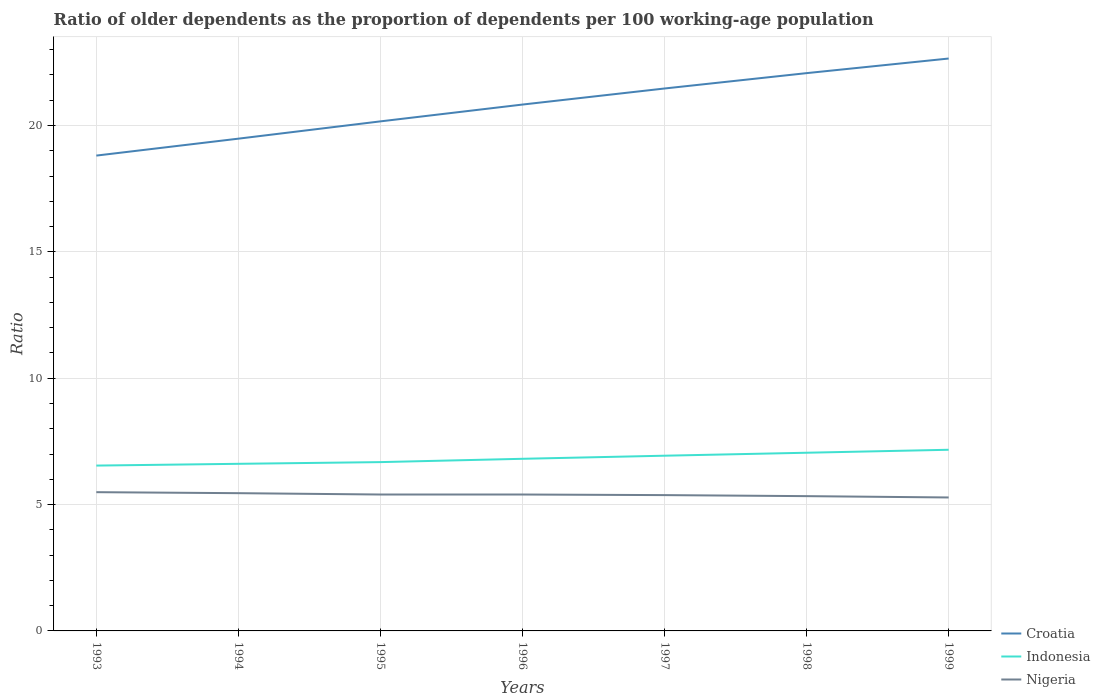How many different coloured lines are there?
Your response must be concise. 3. Does the line corresponding to Croatia intersect with the line corresponding to Nigeria?
Make the answer very short. No. Across all years, what is the maximum age dependency ratio(old) in Croatia?
Give a very brief answer. 18.81. In which year was the age dependency ratio(old) in Nigeria maximum?
Keep it short and to the point. 1999. What is the total age dependency ratio(old) in Croatia in the graph?
Your answer should be compact. -0.64. What is the difference between the highest and the second highest age dependency ratio(old) in Croatia?
Offer a very short reply. 3.84. Does the graph contain any zero values?
Make the answer very short. No. Does the graph contain grids?
Your answer should be compact. Yes. What is the title of the graph?
Keep it short and to the point. Ratio of older dependents as the proportion of dependents per 100 working-age population. Does "Virgin Islands" appear as one of the legend labels in the graph?
Your answer should be compact. No. What is the label or title of the Y-axis?
Your response must be concise. Ratio. What is the Ratio of Croatia in 1993?
Ensure brevity in your answer.  18.81. What is the Ratio of Indonesia in 1993?
Your answer should be very brief. 6.54. What is the Ratio of Nigeria in 1993?
Your answer should be compact. 5.49. What is the Ratio of Croatia in 1994?
Your response must be concise. 19.48. What is the Ratio in Indonesia in 1994?
Make the answer very short. 6.61. What is the Ratio in Nigeria in 1994?
Provide a short and direct response. 5.45. What is the Ratio of Croatia in 1995?
Your response must be concise. 20.16. What is the Ratio in Indonesia in 1995?
Provide a short and direct response. 6.68. What is the Ratio in Nigeria in 1995?
Offer a terse response. 5.4. What is the Ratio in Croatia in 1996?
Provide a succinct answer. 20.83. What is the Ratio in Indonesia in 1996?
Your response must be concise. 6.81. What is the Ratio of Nigeria in 1996?
Keep it short and to the point. 5.4. What is the Ratio in Croatia in 1997?
Make the answer very short. 21.46. What is the Ratio in Indonesia in 1997?
Your response must be concise. 6.93. What is the Ratio of Nigeria in 1997?
Offer a very short reply. 5.37. What is the Ratio of Croatia in 1998?
Your answer should be compact. 22.07. What is the Ratio in Indonesia in 1998?
Your response must be concise. 7.05. What is the Ratio of Nigeria in 1998?
Your answer should be compact. 5.33. What is the Ratio in Croatia in 1999?
Your response must be concise. 22.65. What is the Ratio of Indonesia in 1999?
Your response must be concise. 7.17. What is the Ratio of Nigeria in 1999?
Provide a short and direct response. 5.28. Across all years, what is the maximum Ratio in Croatia?
Offer a terse response. 22.65. Across all years, what is the maximum Ratio of Indonesia?
Your answer should be compact. 7.17. Across all years, what is the maximum Ratio of Nigeria?
Provide a succinct answer. 5.49. Across all years, what is the minimum Ratio of Croatia?
Your answer should be very brief. 18.81. Across all years, what is the minimum Ratio of Indonesia?
Offer a terse response. 6.54. Across all years, what is the minimum Ratio of Nigeria?
Offer a very short reply. 5.28. What is the total Ratio of Croatia in the graph?
Provide a short and direct response. 145.47. What is the total Ratio of Indonesia in the graph?
Give a very brief answer. 47.8. What is the total Ratio in Nigeria in the graph?
Ensure brevity in your answer.  37.73. What is the difference between the Ratio of Croatia in 1993 and that in 1994?
Ensure brevity in your answer.  -0.67. What is the difference between the Ratio in Indonesia in 1993 and that in 1994?
Your answer should be very brief. -0.07. What is the difference between the Ratio in Nigeria in 1993 and that in 1994?
Ensure brevity in your answer.  0.04. What is the difference between the Ratio of Croatia in 1993 and that in 1995?
Provide a succinct answer. -1.35. What is the difference between the Ratio of Indonesia in 1993 and that in 1995?
Offer a very short reply. -0.14. What is the difference between the Ratio of Nigeria in 1993 and that in 1995?
Your answer should be compact. 0.09. What is the difference between the Ratio of Croatia in 1993 and that in 1996?
Ensure brevity in your answer.  -2.02. What is the difference between the Ratio of Indonesia in 1993 and that in 1996?
Make the answer very short. -0.27. What is the difference between the Ratio in Nigeria in 1993 and that in 1996?
Your response must be concise. 0.09. What is the difference between the Ratio of Croatia in 1993 and that in 1997?
Give a very brief answer. -2.65. What is the difference between the Ratio of Indonesia in 1993 and that in 1997?
Keep it short and to the point. -0.39. What is the difference between the Ratio of Nigeria in 1993 and that in 1997?
Give a very brief answer. 0.12. What is the difference between the Ratio in Croatia in 1993 and that in 1998?
Ensure brevity in your answer.  -3.26. What is the difference between the Ratio in Indonesia in 1993 and that in 1998?
Offer a terse response. -0.51. What is the difference between the Ratio of Nigeria in 1993 and that in 1998?
Provide a short and direct response. 0.16. What is the difference between the Ratio in Croatia in 1993 and that in 1999?
Provide a short and direct response. -3.84. What is the difference between the Ratio in Indonesia in 1993 and that in 1999?
Offer a terse response. -0.63. What is the difference between the Ratio in Nigeria in 1993 and that in 1999?
Offer a very short reply. 0.21. What is the difference between the Ratio in Croatia in 1994 and that in 1995?
Your response must be concise. -0.68. What is the difference between the Ratio of Indonesia in 1994 and that in 1995?
Offer a terse response. -0.07. What is the difference between the Ratio of Nigeria in 1994 and that in 1995?
Your answer should be compact. 0.05. What is the difference between the Ratio in Croatia in 1994 and that in 1996?
Provide a short and direct response. -1.35. What is the difference between the Ratio of Indonesia in 1994 and that in 1996?
Provide a succinct answer. -0.2. What is the difference between the Ratio in Nigeria in 1994 and that in 1996?
Offer a terse response. 0.05. What is the difference between the Ratio in Croatia in 1994 and that in 1997?
Keep it short and to the point. -1.99. What is the difference between the Ratio of Indonesia in 1994 and that in 1997?
Give a very brief answer. -0.32. What is the difference between the Ratio of Nigeria in 1994 and that in 1997?
Your response must be concise. 0.08. What is the difference between the Ratio of Croatia in 1994 and that in 1998?
Make the answer very short. -2.59. What is the difference between the Ratio in Indonesia in 1994 and that in 1998?
Provide a short and direct response. -0.44. What is the difference between the Ratio in Nigeria in 1994 and that in 1998?
Provide a succinct answer. 0.12. What is the difference between the Ratio in Croatia in 1994 and that in 1999?
Give a very brief answer. -3.17. What is the difference between the Ratio of Indonesia in 1994 and that in 1999?
Make the answer very short. -0.56. What is the difference between the Ratio in Nigeria in 1994 and that in 1999?
Your answer should be compact. 0.17. What is the difference between the Ratio of Croatia in 1995 and that in 1996?
Ensure brevity in your answer.  -0.67. What is the difference between the Ratio of Indonesia in 1995 and that in 1996?
Your response must be concise. -0.13. What is the difference between the Ratio in Croatia in 1995 and that in 1997?
Provide a succinct answer. -1.3. What is the difference between the Ratio in Indonesia in 1995 and that in 1997?
Provide a short and direct response. -0.25. What is the difference between the Ratio of Nigeria in 1995 and that in 1997?
Provide a short and direct response. 0.02. What is the difference between the Ratio of Croatia in 1995 and that in 1998?
Your answer should be compact. -1.91. What is the difference between the Ratio in Indonesia in 1995 and that in 1998?
Your answer should be very brief. -0.37. What is the difference between the Ratio in Nigeria in 1995 and that in 1998?
Provide a short and direct response. 0.06. What is the difference between the Ratio of Croatia in 1995 and that in 1999?
Your answer should be compact. -2.49. What is the difference between the Ratio in Indonesia in 1995 and that in 1999?
Keep it short and to the point. -0.49. What is the difference between the Ratio of Nigeria in 1995 and that in 1999?
Ensure brevity in your answer.  0.12. What is the difference between the Ratio of Croatia in 1996 and that in 1997?
Provide a succinct answer. -0.64. What is the difference between the Ratio in Indonesia in 1996 and that in 1997?
Provide a short and direct response. -0.12. What is the difference between the Ratio of Nigeria in 1996 and that in 1997?
Your response must be concise. 0.02. What is the difference between the Ratio of Croatia in 1996 and that in 1998?
Provide a succinct answer. -1.24. What is the difference between the Ratio in Indonesia in 1996 and that in 1998?
Make the answer very short. -0.24. What is the difference between the Ratio of Nigeria in 1996 and that in 1998?
Your answer should be very brief. 0.06. What is the difference between the Ratio of Croatia in 1996 and that in 1999?
Keep it short and to the point. -1.82. What is the difference between the Ratio in Indonesia in 1996 and that in 1999?
Your response must be concise. -0.36. What is the difference between the Ratio in Nigeria in 1996 and that in 1999?
Keep it short and to the point. 0.12. What is the difference between the Ratio of Croatia in 1997 and that in 1998?
Offer a very short reply. -0.61. What is the difference between the Ratio in Indonesia in 1997 and that in 1998?
Provide a short and direct response. -0.12. What is the difference between the Ratio in Nigeria in 1997 and that in 1998?
Give a very brief answer. 0.04. What is the difference between the Ratio of Croatia in 1997 and that in 1999?
Keep it short and to the point. -1.19. What is the difference between the Ratio of Indonesia in 1997 and that in 1999?
Your answer should be very brief. -0.24. What is the difference between the Ratio in Nigeria in 1997 and that in 1999?
Provide a succinct answer. 0.09. What is the difference between the Ratio of Croatia in 1998 and that in 1999?
Provide a short and direct response. -0.58. What is the difference between the Ratio in Indonesia in 1998 and that in 1999?
Offer a very short reply. -0.12. What is the difference between the Ratio in Nigeria in 1998 and that in 1999?
Keep it short and to the point. 0.05. What is the difference between the Ratio in Croatia in 1993 and the Ratio in Indonesia in 1994?
Offer a very short reply. 12.2. What is the difference between the Ratio in Croatia in 1993 and the Ratio in Nigeria in 1994?
Your response must be concise. 13.36. What is the difference between the Ratio of Indonesia in 1993 and the Ratio of Nigeria in 1994?
Provide a succinct answer. 1.09. What is the difference between the Ratio in Croatia in 1993 and the Ratio in Indonesia in 1995?
Your response must be concise. 12.13. What is the difference between the Ratio of Croatia in 1993 and the Ratio of Nigeria in 1995?
Your answer should be very brief. 13.41. What is the difference between the Ratio of Indonesia in 1993 and the Ratio of Nigeria in 1995?
Your answer should be compact. 1.14. What is the difference between the Ratio of Croatia in 1993 and the Ratio of Indonesia in 1996?
Provide a succinct answer. 12. What is the difference between the Ratio of Croatia in 1993 and the Ratio of Nigeria in 1996?
Offer a very short reply. 13.41. What is the difference between the Ratio of Indonesia in 1993 and the Ratio of Nigeria in 1996?
Offer a very short reply. 1.15. What is the difference between the Ratio of Croatia in 1993 and the Ratio of Indonesia in 1997?
Provide a short and direct response. 11.88. What is the difference between the Ratio in Croatia in 1993 and the Ratio in Nigeria in 1997?
Provide a succinct answer. 13.44. What is the difference between the Ratio in Indonesia in 1993 and the Ratio in Nigeria in 1997?
Provide a short and direct response. 1.17. What is the difference between the Ratio of Croatia in 1993 and the Ratio of Indonesia in 1998?
Make the answer very short. 11.76. What is the difference between the Ratio of Croatia in 1993 and the Ratio of Nigeria in 1998?
Offer a terse response. 13.48. What is the difference between the Ratio in Indonesia in 1993 and the Ratio in Nigeria in 1998?
Make the answer very short. 1.21. What is the difference between the Ratio of Croatia in 1993 and the Ratio of Indonesia in 1999?
Keep it short and to the point. 11.64. What is the difference between the Ratio in Croatia in 1993 and the Ratio in Nigeria in 1999?
Make the answer very short. 13.53. What is the difference between the Ratio in Indonesia in 1993 and the Ratio in Nigeria in 1999?
Provide a succinct answer. 1.26. What is the difference between the Ratio in Croatia in 1994 and the Ratio in Indonesia in 1995?
Offer a terse response. 12.8. What is the difference between the Ratio in Croatia in 1994 and the Ratio in Nigeria in 1995?
Your response must be concise. 14.08. What is the difference between the Ratio of Indonesia in 1994 and the Ratio of Nigeria in 1995?
Ensure brevity in your answer.  1.21. What is the difference between the Ratio in Croatia in 1994 and the Ratio in Indonesia in 1996?
Ensure brevity in your answer.  12.67. What is the difference between the Ratio of Croatia in 1994 and the Ratio of Nigeria in 1996?
Ensure brevity in your answer.  14.08. What is the difference between the Ratio in Indonesia in 1994 and the Ratio in Nigeria in 1996?
Your answer should be very brief. 1.22. What is the difference between the Ratio in Croatia in 1994 and the Ratio in Indonesia in 1997?
Give a very brief answer. 12.55. What is the difference between the Ratio in Croatia in 1994 and the Ratio in Nigeria in 1997?
Give a very brief answer. 14.11. What is the difference between the Ratio in Indonesia in 1994 and the Ratio in Nigeria in 1997?
Your answer should be compact. 1.24. What is the difference between the Ratio of Croatia in 1994 and the Ratio of Indonesia in 1998?
Your answer should be very brief. 12.43. What is the difference between the Ratio of Croatia in 1994 and the Ratio of Nigeria in 1998?
Your answer should be very brief. 14.15. What is the difference between the Ratio in Indonesia in 1994 and the Ratio in Nigeria in 1998?
Ensure brevity in your answer.  1.28. What is the difference between the Ratio in Croatia in 1994 and the Ratio in Indonesia in 1999?
Offer a very short reply. 12.31. What is the difference between the Ratio in Croatia in 1994 and the Ratio in Nigeria in 1999?
Your answer should be compact. 14.2. What is the difference between the Ratio of Indonesia in 1994 and the Ratio of Nigeria in 1999?
Your answer should be very brief. 1.33. What is the difference between the Ratio in Croatia in 1995 and the Ratio in Indonesia in 1996?
Ensure brevity in your answer.  13.35. What is the difference between the Ratio of Croatia in 1995 and the Ratio of Nigeria in 1996?
Your answer should be compact. 14.77. What is the difference between the Ratio of Indonesia in 1995 and the Ratio of Nigeria in 1996?
Your response must be concise. 1.28. What is the difference between the Ratio of Croatia in 1995 and the Ratio of Indonesia in 1997?
Offer a very short reply. 13.23. What is the difference between the Ratio in Croatia in 1995 and the Ratio in Nigeria in 1997?
Your answer should be compact. 14.79. What is the difference between the Ratio of Indonesia in 1995 and the Ratio of Nigeria in 1997?
Your response must be concise. 1.31. What is the difference between the Ratio of Croatia in 1995 and the Ratio of Indonesia in 1998?
Provide a succinct answer. 13.11. What is the difference between the Ratio of Croatia in 1995 and the Ratio of Nigeria in 1998?
Make the answer very short. 14.83. What is the difference between the Ratio of Indonesia in 1995 and the Ratio of Nigeria in 1998?
Offer a very short reply. 1.35. What is the difference between the Ratio in Croatia in 1995 and the Ratio in Indonesia in 1999?
Give a very brief answer. 12.99. What is the difference between the Ratio of Croatia in 1995 and the Ratio of Nigeria in 1999?
Your answer should be compact. 14.88. What is the difference between the Ratio in Indonesia in 1995 and the Ratio in Nigeria in 1999?
Make the answer very short. 1.4. What is the difference between the Ratio in Croatia in 1996 and the Ratio in Indonesia in 1997?
Give a very brief answer. 13.9. What is the difference between the Ratio of Croatia in 1996 and the Ratio of Nigeria in 1997?
Your answer should be very brief. 15.45. What is the difference between the Ratio in Indonesia in 1996 and the Ratio in Nigeria in 1997?
Make the answer very short. 1.44. What is the difference between the Ratio of Croatia in 1996 and the Ratio of Indonesia in 1998?
Your answer should be compact. 13.78. What is the difference between the Ratio of Croatia in 1996 and the Ratio of Nigeria in 1998?
Make the answer very short. 15.5. What is the difference between the Ratio of Indonesia in 1996 and the Ratio of Nigeria in 1998?
Provide a succinct answer. 1.48. What is the difference between the Ratio in Croatia in 1996 and the Ratio in Indonesia in 1999?
Ensure brevity in your answer.  13.66. What is the difference between the Ratio in Croatia in 1996 and the Ratio in Nigeria in 1999?
Your answer should be compact. 15.55. What is the difference between the Ratio of Indonesia in 1996 and the Ratio of Nigeria in 1999?
Offer a terse response. 1.53. What is the difference between the Ratio of Croatia in 1997 and the Ratio of Indonesia in 1998?
Give a very brief answer. 14.41. What is the difference between the Ratio of Croatia in 1997 and the Ratio of Nigeria in 1998?
Make the answer very short. 16.13. What is the difference between the Ratio of Croatia in 1997 and the Ratio of Indonesia in 1999?
Your response must be concise. 14.3. What is the difference between the Ratio in Croatia in 1997 and the Ratio in Nigeria in 1999?
Your answer should be compact. 16.18. What is the difference between the Ratio in Indonesia in 1997 and the Ratio in Nigeria in 1999?
Ensure brevity in your answer.  1.65. What is the difference between the Ratio of Croatia in 1998 and the Ratio of Indonesia in 1999?
Your response must be concise. 14.9. What is the difference between the Ratio in Croatia in 1998 and the Ratio in Nigeria in 1999?
Your answer should be very brief. 16.79. What is the difference between the Ratio in Indonesia in 1998 and the Ratio in Nigeria in 1999?
Offer a very short reply. 1.77. What is the average Ratio in Croatia per year?
Provide a short and direct response. 20.78. What is the average Ratio of Indonesia per year?
Give a very brief answer. 6.83. What is the average Ratio in Nigeria per year?
Keep it short and to the point. 5.39. In the year 1993, what is the difference between the Ratio of Croatia and Ratio of Indonesia?
Provide a succinct answer. 12.27. In the year 1993, what is the difference between the Ratio of Croatia and Ratio of Nigeria?
Your answer should be very brief. 13.32. In the year 1993, what is the difference between the Ratio of Indonesia and Ratio of Nigeria?
Give a very brief answer. 1.05. In the year 1994, what is the difference between the Ratio in Croatia and Ratio in Indonesia?
Offer a very short reply. 12.87. In the year 1994, what is the difference between the Ratio in Croatia and Ratio in Nigeria?
Your answer should be very brief. 14.03. In the year 1994, what is the difference between the Ratio of Indonesia and Ratio of Nigeria?
Your response must be concise. 1.16. In the year 1995, what is the difference between the Ratio in Croatia and Ratio in Indonesia?
Offer a very short reply. 13.48. In the year 1995, what is the difference between the Ratio in Croatia and Ratio in Nigeria?
Your answer should be compact. 14.77. In the year 1995, what is the difference between the Ratio in Indonesia and Ratio in Nigeria?
Give a very brief answer. 1.28. In the year 1996, what is the difference between the Ratio in Croatia and Ratio in Indonesia?
Your answer should be compact. 14.02. In the year 1996, what is the difference between the Ratio in Croatia and Ratio in Nigeria?
Your response must be concise. 15.43. In the year 1996, what is the difference between the Ratio in Indonesia and Ratio in Nigeria?
Make the answer very short. 1.41. In the year 1997, what is the difference between the Ratio in Croatia and Ratio in Indonesia?
Your answer should be compact. 14.53. In the year 1997, what is the difference between the Ratio in Croatia and Ratio in Nigeria?
Your response must be concise. 16.09. In the year 1997, what is the difference between the Ratio of Indonesia and Ratio of Nigeria?
Ensure brevity in your answer.  1.56. In the year 1998, what is the difference between the Ratio in Croatia and Ratio in Indonesia?
Provide a succinct answer. 15.02. In the year 1998, what is the difference between the Ratio of Croatia and Ratio of Nigeria?
Your answer should be very brief. 16.74. In the year 1998, what is the difference between the Ratio in Indonesia and Ratio in Nigeria?
Your answer should be very brief. 1.72. In the year 1999, what is the difference between the Ratio of Croatia and Ratio of Indonesia?
Provide a short and direct response. 15.48. In the year 1999, what is the difference between the Ratio in Croatia and Ratio in Nigeria?
Keep it short and to the point. 17.37. In the year 1999, what is the difference between the Ratio of Indonesia and Ratio of Nigeria?
Ensure brevity in your answer.  1.89. What is the ratio of the Ratio of Croatia in 1993 to that in 1994?
Offer a terse response. 0.97. What is the ratio of the Ratio in Nigeria in 1993 to that in 1994?
Your response must be concise. 1.01. What is the ratio of the Ratio in Croatia in 1993 to that in 1995?
Provide a short and direct response. 0.93. What is the ratio of the Ratio of Indonesia in 1993 to that in 1995?
Give a very brief answer. 0.98. What is the ratio of the Ratio of Nigeria in 1993 to that in 1995?
Offer a very short reply. 1.02. What is the ratio of the Ratio in Croatia in 1993 to that in 1996?
Give a very brief answer. 0.9. What is the ratio of the Ratio in Indonesia in 1993 to that in 1996?
Keep it short and to the point. 0.96. What is the ratio of the Ratio in Nigeria in 1993 to that in 1996?
Your answer should be very brief. 1.02. What is the ratio of the Ratio in Croatia in 1993 to that in 1997?
Offer a terse response. 0.88. What is the ratio of the Ratio of Indonesia in 1993 to that in 1997?
Keep it short and to the point. 0.94. What is the ratio of the Ratio in Nigeria in 1993 to that in 1997?
Your answer should be compact. 1.02. What is the ratio of the Ratio in Croatia in 1993 to that in 1998?
Keep it short and to the point. 0.85. What is the ratio of the Ratio of Indonesia in 1993 to that in 1998?
Ensure brevity in your answer.  0.93. What is the ratio of the Ratio of Nigeria in 1993 to that in 1998?
Offer a terse response. 1.03. What is the ratio of the Ratio in Croatia in 1993 to that in 1999?
Provide a succinct answer. 0.83. What is the ratio of the Ratio of Indonesia in 1993 to that in 1999?
Provide a short and direct response. 0.91. What is the ratio of the Ratio in Nigeria in 1993 to that in 1999?
Give a very brief answer. 1.04. What is the ratio of the Ratio in Croatia in 1994 to that in 1995?
Keep it short and to the point. 0.97. What is the ratio of the Ratio of Nigeria in 1994 to that in 1995?
Keep it short and to the point. 1.01. What is the ratio of the Ratio of Croatia in 1994 to that in 1996?
Keep it short and to the point. 0.94. What is the ratio of the Ratio of Indonesia in 1994 to that in 1996?
Your answer should be compact. 0.97. What is the ratio of the Ratio of Nigeria in 1994 to that in 1996?
Your answer should be compact. 1.01. What is the ratio of the Ratio of Croatia in 1994 to that in 1997?
Offer a very short reply. 0.91. What is the ratio of the Ratio in Indonesia in 1994 to that in 1997?
Offer a very short reply. 0.95. What is the ratio of the Ratio in Nigeria in 1994 to that in 1997?
Make the answer very short. 1.01. What is the ratio of the Ratio in Croatia in 1994 to that in 1998?
Provide a succinct answer. 0.88. What is the ratio of the Ratio in Indonesia in 1994 to that in 1998?
Your answer should be compact. 0.94. What is the ratio of the Ratio of Croatia in 1994 to that in 1999?
Give a very brief answer. 0.86. What is the ratio of the Ratio of Indonesia in 1994 to that in 1999?
Keep it short and to the point. 0.92. What is the ratio of the Ratio in Nigeria in 1994 to that in 1999?
Your answer should be compact. 1.03. What is the ratio of the Ratio in Croatia in 1995 to that in 1996?
Ensure brevity in your answer.  0.97. What is the ratio of the Ratio in Indonesia in 1995 to that in 1996?
Keep it short and to the point. 0.98. What is the ratio of the Ratio of Nigeria in 1995 to that in 1996?
Your answer should be compact. 1. What is the ratio of the Ratio in Croatia in 1995 to that in 1997?
Provide a succinct answer. 0.94. What is the ratio of the Ratio in Indonesia in 1995 to that in 1997?
Provide a short and direct response. 0.96. What is the ratio of the Ratio in Nigeria in 1995 to that in 1997?
Give a very brief answer. 1. What is the ratio of the Ratio in Croatia in 1995 to that in 1998?
Your response must be concise. 0.91. What is the ratio of the Ratio of Indonesia in 1995 to that in 1998?
Offer a very short reply. 0.95. What is the ratio of the Ratio of Nigeria in 1995 to that in 1998?
Ensure brevity in your answer.  1.01. What is the ratio of the Ratio in Croatia in 1995 to that in 1999?
Offer a very short reply. 0.89. What is the ratio of the Ratio of Indonesia in 1995 to that in 1999?
Provide a succinct answer. 0.93. What is the ratio of the Ratio of Nigeria in 1995 to that in 1999?
Make the answer very short. 1.02. What is the ratio of the Ratio of Croatia in 1996 to that in 1997?
Provide a succinct answer. 0.97. What is the ratio of the Ratio in Indonesia in 1996 to that in 1997?
Your answer should be very brief. 0.98. What is the ratio of the Ratio in Nigeria in 1996 to that in 1997?
Your answer should be very brief. 1. What is the ratio of the Ratio of Croatia in 1996 to that in 1998?
Make the answer very short. 0.94. What is the ratio of the Ratio in Indonesia in 1996 to that in 1998?
Offer a very short reply. 0.97. What is the ratio of the Ratio of Croatia in 1996 to that in 1999?
Provide a succinct answer. 0.92. What is the ratio of the Ratio in Indonesia in 1996 to that in 1999?
Give a very brief answer. 0.95. What is the ratio of the Ratio in Nigeria in 1996 to that in 1999?
Offer a very short reply. 1.02. What is the ratio of the Ratio of Croatia in 1997 to that in 1998?
Your response must be concise. 0.97. What is the ratio of the Ratio of Indonesia in 1997 to that in 1998?
Ensure brevity in your answer.  0.98. What is the ratio of the Ratio in Nigeria in 1997 to that in 1998?
Keep it short and to the point. 1.01. What is the ratio of the Ratio of Croatia in 1997 to that in 1999?
Make the answer very short. 0.95. What is the ratio of the Ratio of Indonesia in 1997 to that in 1999?
Keep it short and to the point. 0.97. What is the ratio of the Ratio in Nigeria in 1997 to that in 1999?
Keep it short and to the point. 1.02. What is the ratio of the Ratio of Croatia in 1998 to that in 1999?
Offer a very short reply. 0.97. What is the ratio of the Ratio in Indonesia in 1998 to that in 1999?
Make the answer very short. 0.98. What is the ratio of the Ratio of Nigeria in 1998 to that in 1999?
Offer a very short reply. 1.01. What is the difference between the highest and the second highest Ratio of Croatia?
Ensure brevity in your answer.  0.58. What is the difference between the highest and the second highest Ratio in Indonesia?
Offer a terse response. 0.12. What is the difference between the highest and the second highest Ratio in Nigeria?
Keep it short and to the point. 0.04. What is the difference between the highest and the lowest Ratio of Croatia?
Your response must be concise. 3.84. What is the difference between the highest and the lowest Ratio of Indonesia?
Offer a very short reply. 0.63. What is the difference between the highest and the lowest Ratio in Nigeria?
Offer a terse response. 0.21. 